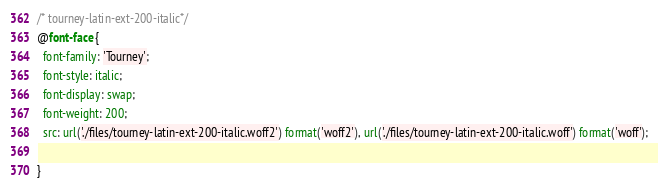Convert code to text. <code><loc_0><loc_0><loc_500><loc_500><_CSS_>/* tourney-latin-ext-200-italic*/
@font-face {
  font-family: 'Tourney';
  font-style: italic;
  font-display: swap;
  font-weight: 200;
  src: url('./files/tourney-latin-ext-200-italic.woff2') format('woff2'), url('./files/tourney-latin-ext-200-italic.woff') format('woff');
  
}
</code> 